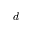Convert formula to latex. <formula><loc_0><loc_0><loc_500><loc_500>d</formula> 